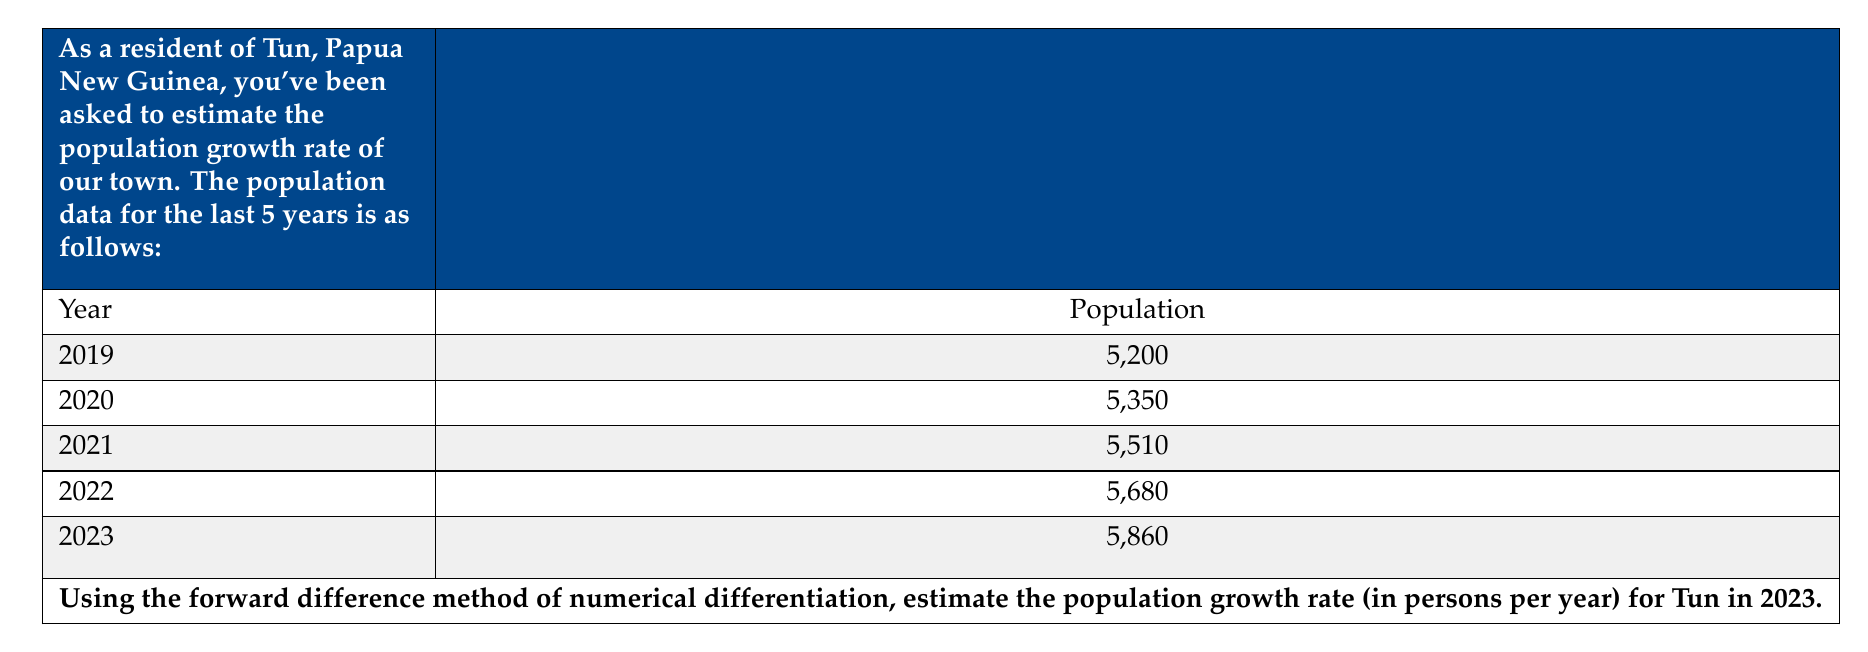What is the answer to this math problem? To estimate the population growth rate using the forward difference method, we'll follow these steps:

1) The forward difference formula for the first derivative (growth rate) is:

   $$f'(x) \approx \frac{f(x+h) - f(x)}{h}$$

   Where $h$ is the step size (in our case, 1 year).

2) For 2023, we don't have data for 2024, so we'll use the backward difference:

   $$f'(2023) \approx \frac{f(2023) - f(2022)}{2023 - 2022}$$

3) Substituting the values:

   $$\text{Growth Rate} \approx \frac{5860 - 5680}{1} = 180$$

4) Therefore, the estimated population growth rate for Tun in 2023 is 180 persons per year.

5) We can verify this by calculating the average growth rate over the entire period:

   $$\text{Average Growth Rate} = \frac{5860 - 5200}{2023 - 2019} = \frac{660}{4} = 165$$

   This shows our estimate is reasonable, as it's close to but slightly higher than the average, which is expected in a growing population.
Answer: 180 persons/year 